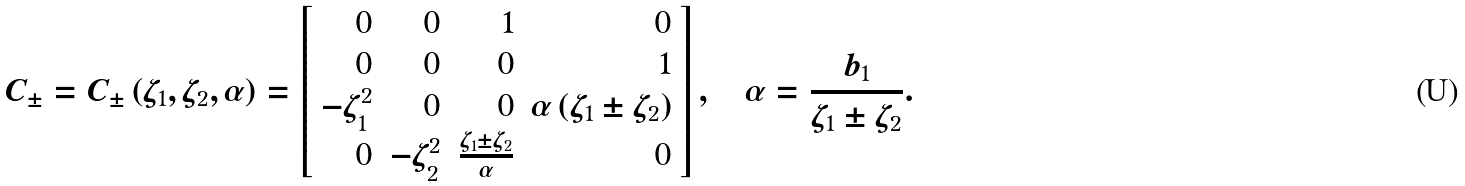<formula> <loc_0><loc_0><loc_500><loc_500>C _ { \pm } = C _ { \pm } \left ( \zeta _ { 1 } , \zeta _ { 2 } , \alpha \right ) = \left [ \begin{array} { r r r r } 0 & 0 & 1 & 0 \\ 0 & 0 & 0 & 1 \\ - \zeta _ { 1 } ^ { 2 } & 0 & 0 & \alpha \left ( \zeta _ { 1 } \pm \zeta _ { 2 } \right ) \\ 0 & - \zeta _ { 2 } ^ { 2 } & \frac { \zeta _ { 1 } \pm \zeta _ { 2 } } { \alpha } & 0 \end{array} \right ] , \quad \alpha = \frac { b _ { 1 } } { \zeta _ { 1 } \pm \zeta _ { 2 } } .</formula> 